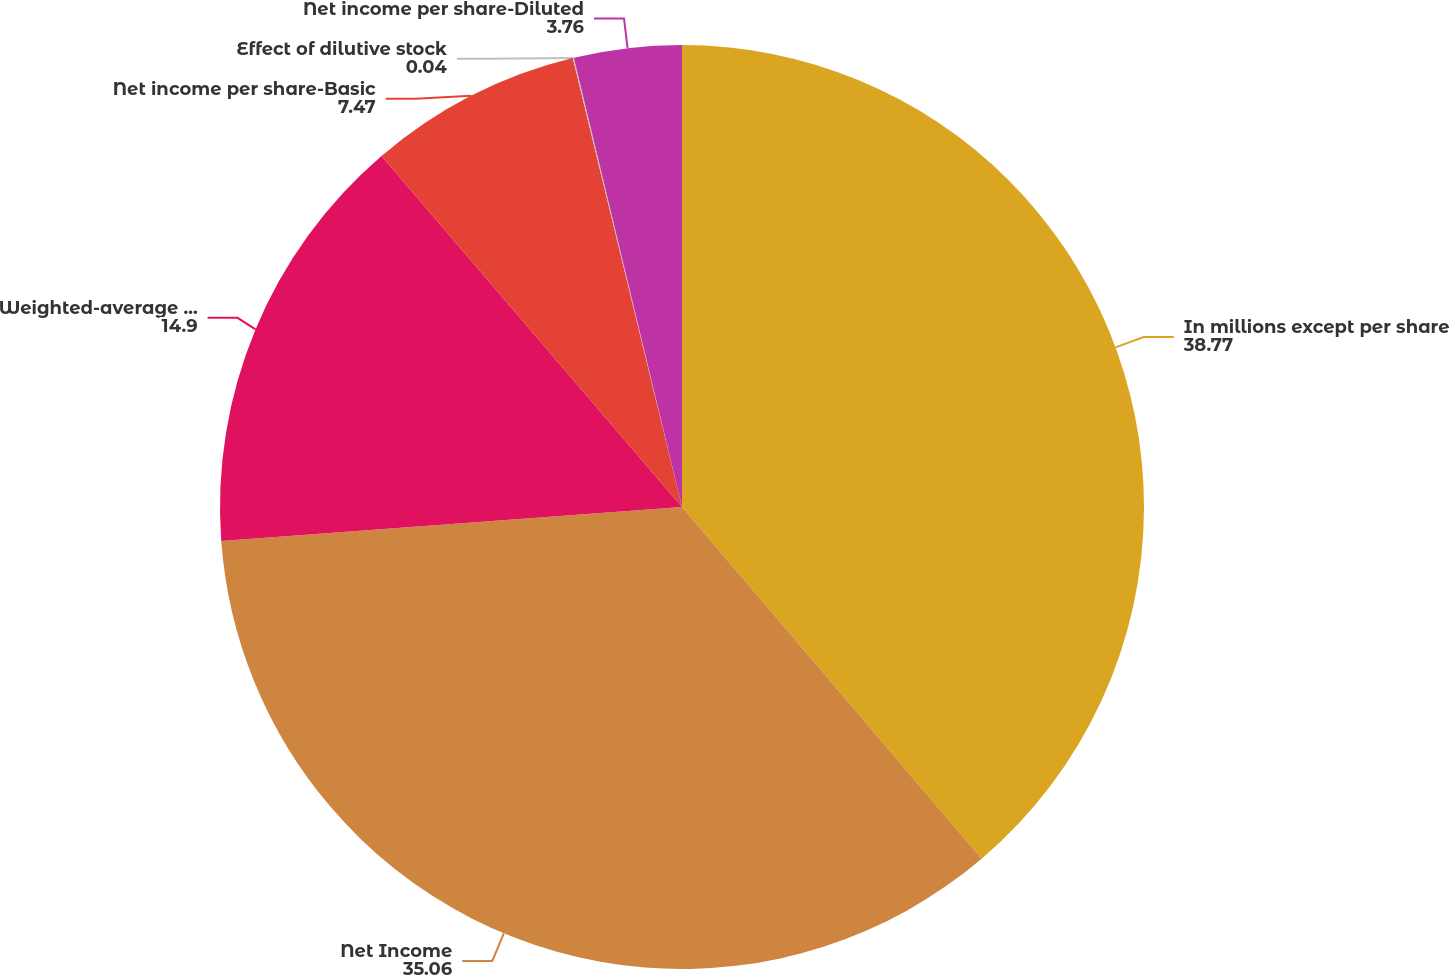<chart> <loc_0><loc_0><loc_500><loc_500><pie_chart><fcel>In millions except per share<fcel>Net Income<fcel>Weighted-average common shares<fcel>Net income per share-Basic<fcel>Effect of dilutive stock<fcel>Net income per share-Diluted<nl><fcel>38.77%<fcel>35.06%<fcel>14.9%<fcel>7.47%<fcel>0.04%<fcel>3.76%<nl></chart> 